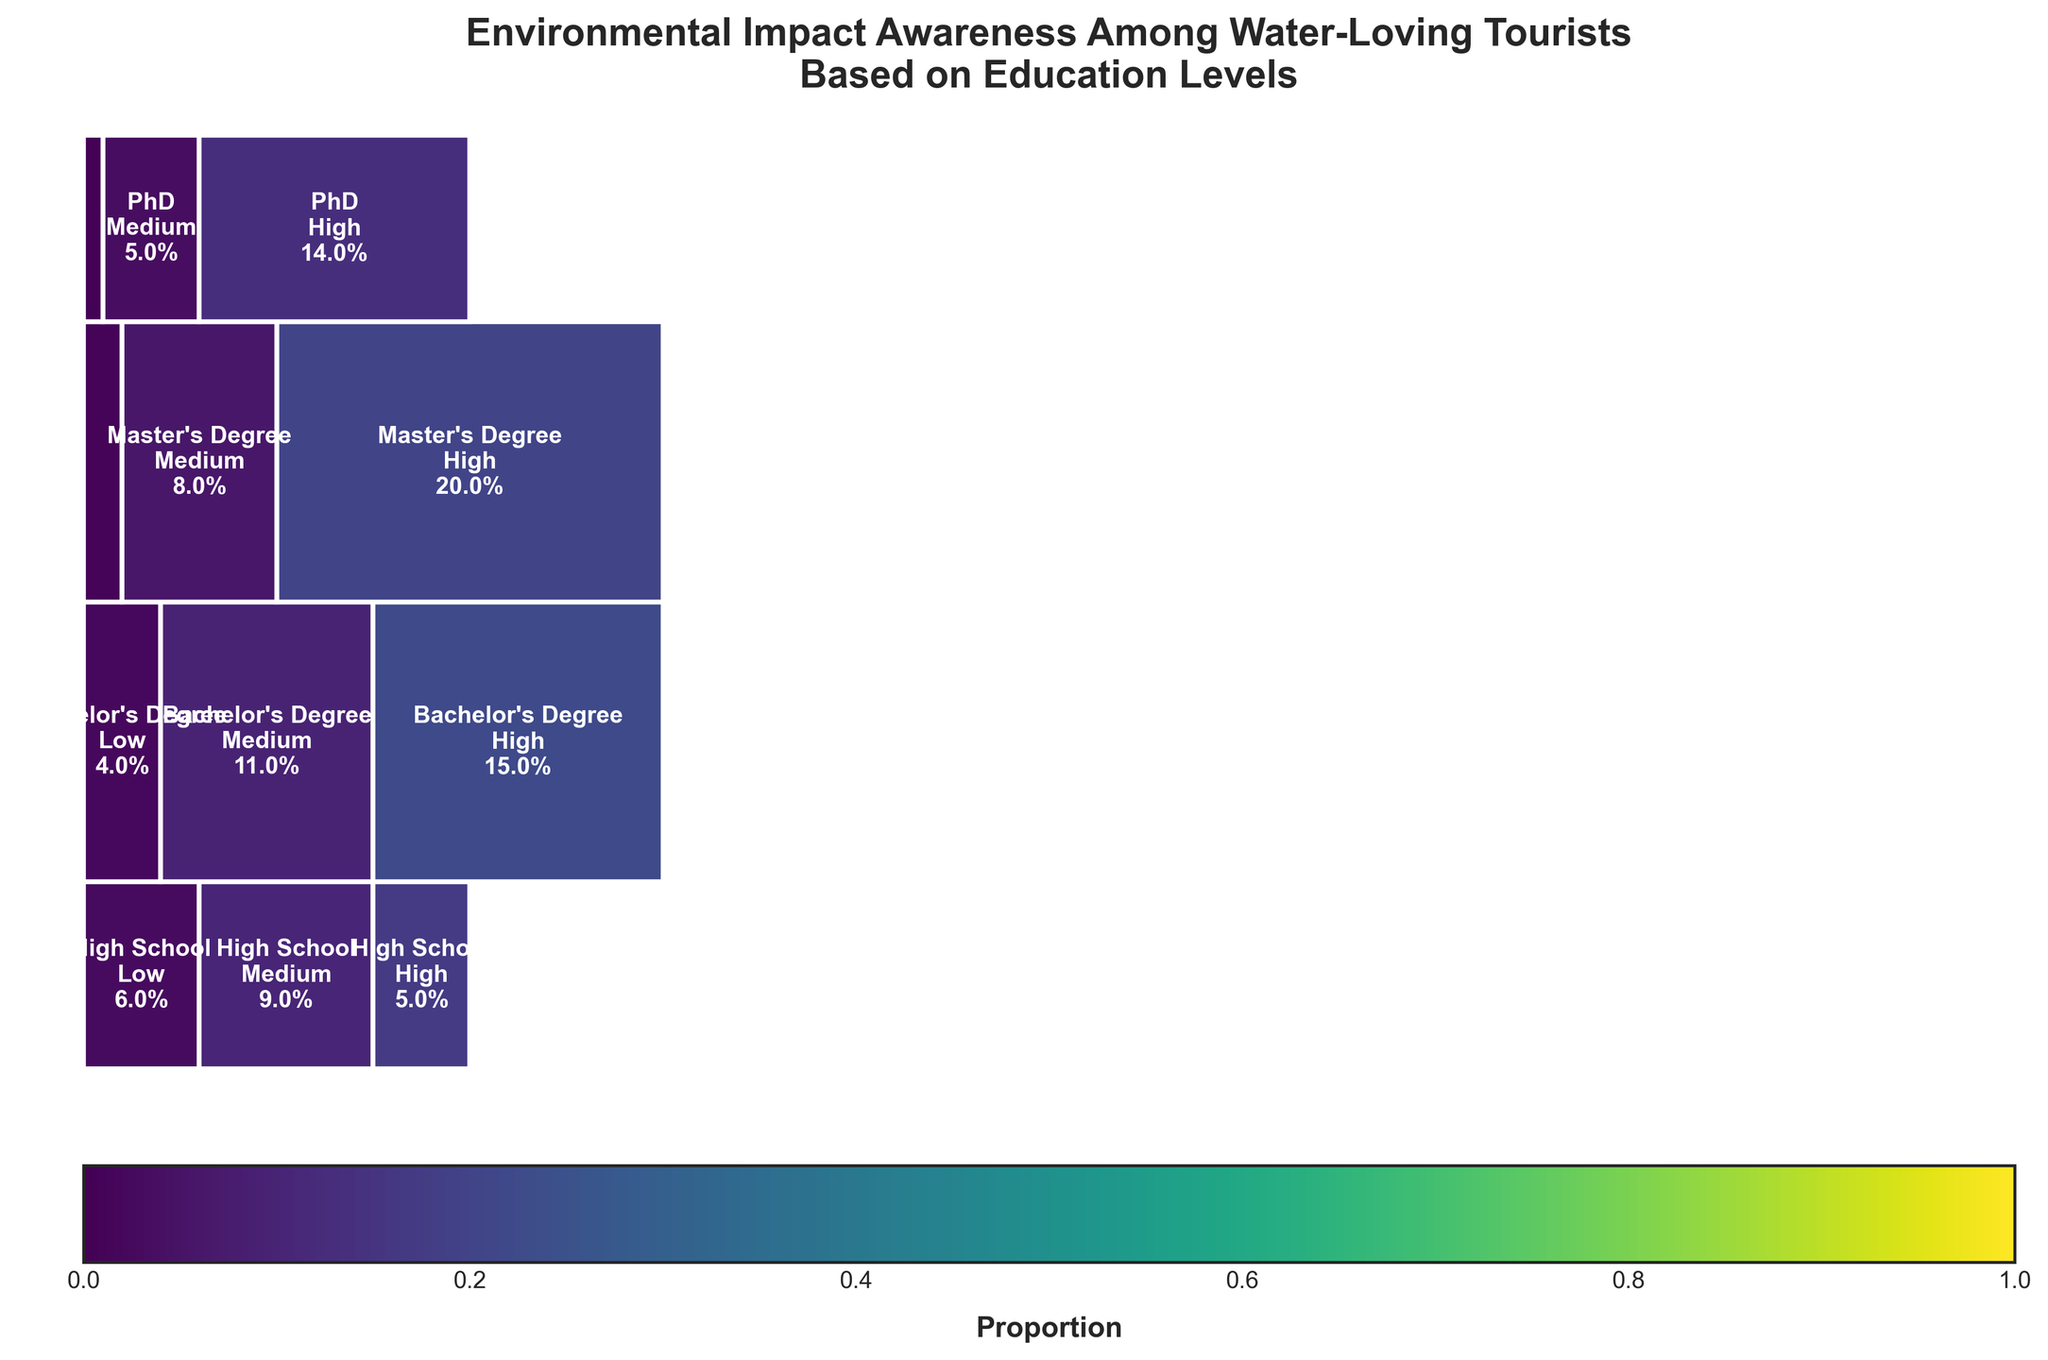What is the title of the figure? The title is located at the top of the figure and provides an overview of the content. It reads "Environmental Impact Awareness Among Water-Loving Tourists Based on Education Levels."
Answer: Environmental Impact Awareness Among Water-Loving Tourists Based on Education Levels Which education level shows the highest awareness level of environmental impact? The height of each segment in the mosaic plot corresponds to the proportion of each awareness level. The segment for "Master's Degree" with "High" awareness is the tallest.
Answer: Master's Degree In the category "High School," what proportion of tourists have a high level of environmental impact awareness compared to those with a medium level? By examining the width proportions of each awareness level within the "High School" category, we see "High" awareness is narrower compared to "Medium." The plot indicates 100 for "High" and 180 for "Medium."
Answer: 100 out of 280 Compare the proportion of tourists with a Bachelor's Degree who have medium environmental impact awareness to those with a PhD and low awareness. The widths for "Medium" awareness among Bachelor's Degree holders (220) and "Low" awareness among PhD holders (20) are compared proportionally within their respective education levels. Bachelor's Degree category shows a significantly larger segment.
Answer: Larger for Bachelor's Degree with Medium awareness Which education level and awareness level combination has the smallest proportion? The smallest rectangle is for "PhD" level with "Low" awareness of environmental impact. It occupies the least space in the plot.
Answer: PhD with Low awareness What is the total number of tourists with medium environmental impact awareness across all education levels? Summing up the frequencies for "Medium" awareness in all education categories: 180 (High School) + 220 (Bachelor's) + 160 (Master's) + 100 (PhD) = 660.
Answer: 660 Is the proportion of "High" environmental impact awareness larger for tourists with a Master's Degree compared to those with a PhD? Observing the plot, the rectangle for Master's Degree with "High" awareness is taller than that for PhD with "High" awareness, indicating a larger proportion.
Answer: Yes What percentage of tourists with a High School education level are aware of environmental impact at a medium level? The proportion for "Medium" awareness among High School education is represented by the width of its respective segment: 180 out of (120 + 180 + 100) = 400, thus, (180/400)*100 ≈ 45%.
Answer: 45% If you sum up the number of tourists with low environmental impact awareness for Bachelor's and Master's degrees, how many tourists is that? Adding frequencies for "Low" awareness in these education levels: 80 (Bachelor's) + 40 (Master's) = 120.
Answer: 120 For water-loving tourists with a Bachelor's Degree, which is the most common level of environmental impact awareness? The plot shows the widest segment for Bachelor's Degree tourists is "High" awareness, hence the most common.
Answer: High 